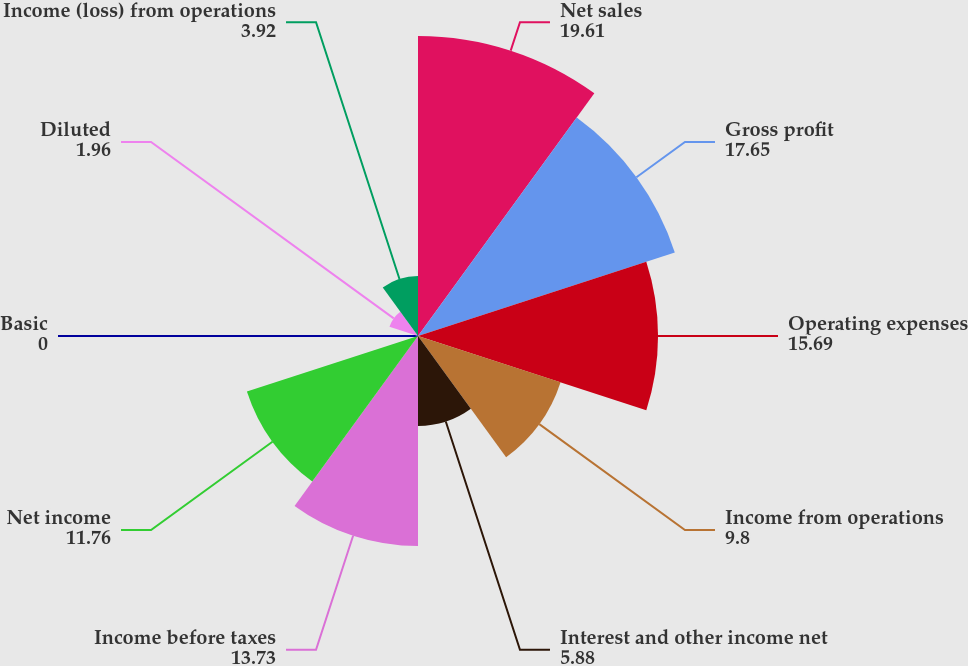Convert chart to OTSL. <chart><loc_0><loc_0><loc_500><loc_500><pie_chart><fcel>Net sales<fcel>Gross profit<fcel>Operating expenses<fcel>Income from operations<fcel>Interest and other income net<fcel>Income before taxes<fcel>Net income<fcel>Basic<fcel>Diluted<fcel>Income (loss) from operations<nl><fcel>19.61%<fcel>17.65%<fcel>15.69%<fcel>9.8%<fcel>5.88%<fcel>13.73%<fcel>11.76%<fcel>0.0%<fcel>1.96%<fcel>3.92%<nl></chart> 